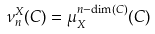<formula> <loc_0><loc_0><loc_500><loc_500>\nu _ { n } ^ { X } ( C ) = \mu _ { X } ^ { n - \dim ( C ) } ( C )</formula> 